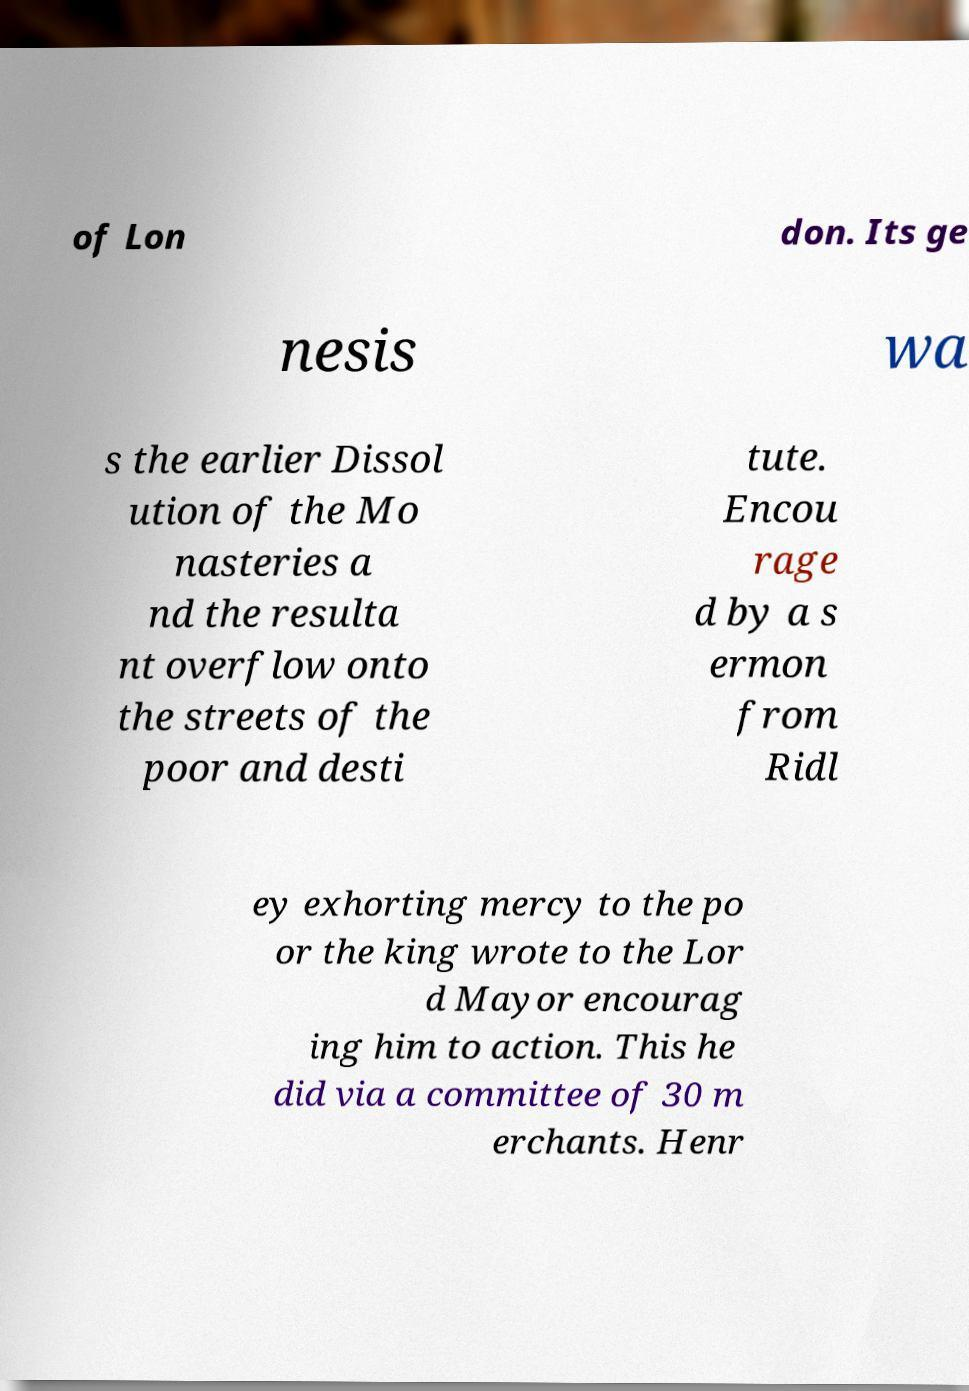Could you assist in decoding the text presented in this image and type it out clearly? of Lon don. Its ge nesis wa s the earlier Dissol ution of the Mo nasteries a nd the resulta nt overflow onto the streets of the poor and desti tute. Encou rage d by a s ermon from Ridl ey exhorting mercy to the po or the king wrote to the Lor d Mayor encourag ing him to action. This he did via a committee of 30 m erchants. Henr 